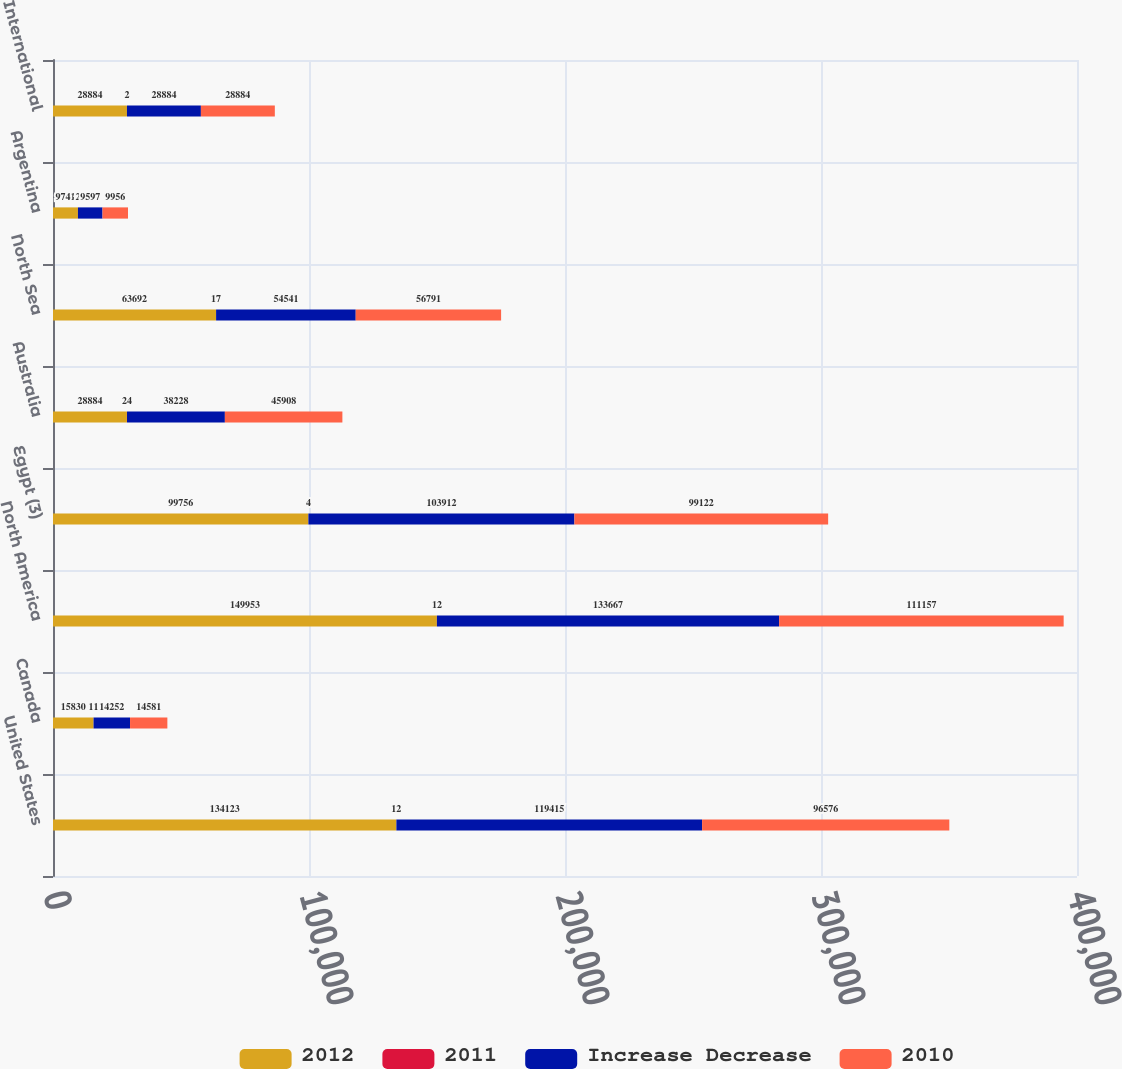<chart> <loc_0><loc_0><loc_500><loc_500><stacked_bar_chart><ecel><fcel>United States<fcel>Canada<fcel>North America<fcel>Egypt (3)<fcel>Australia<fcel>North Sea<fcel>Argentina<fcel>International<nl><fcel>2012<fcel>134123<fcel>15830<fcel>149953<fcel>99756<fcel>28884<fcel>63692<fcel>9741<fcel>28884<nl><fcel>2011<fcel>12<fcel>11<fcel>12<fcel>4<fcel>24<fcel>17<fcel>2<fcel>2<nl><fcel>Increase Decrease<fcel>119415<fcel>14252<fcel>133667<fcel>103912<fcel>38228<fcel>54541<fcel>9597<fcel>28884<nl><fcel>2010<fcel>96576<fcel>14581<fcel>111157<fcel>99122<fcel>45908<fcel>56791<fcel>9956<fcel>28884<nl></chart> 